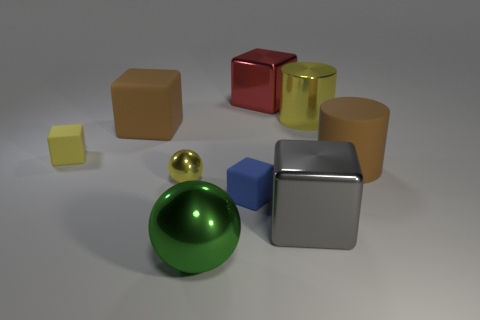Are the large brown cube and the yellow cylinder made of the same material?
Offer a very short reply. No. Is the shiny cylinder the same color as the small ball?
Keep it short and to the point. Yes. There is a yellow metallic object that is on the left side of the red shiny cube; what size is it?
Your answer should be compact. Small. There is a object that is the same color as the big matte cube; what shape is it?
Your response must be concise. Cylinder. Does the brown cylinder have the same material as the ball that is left of the green metallic object?
Your answer should be compact. No. There is a cylinder that is to the left of the large brown thing that is in front of the small yellow rubber object; what number of metallic objects are behind it?
Offer a very short reply. 1. What number of blue things are either shiny things or small cubes?
Your answer should be compact. 1. There is a large brown object that is on the left side of the tiny blue object; what is its shape?
Your answer should be very brief. Cube. What is the color of the metallic ball that is the same size as the gray metal thing?
Make the answer very short. Green. Does the gray thing have the same shape as the tiny matte thing behind the small blue rubber object?
Ensure brevity in your answer.  Yes. 